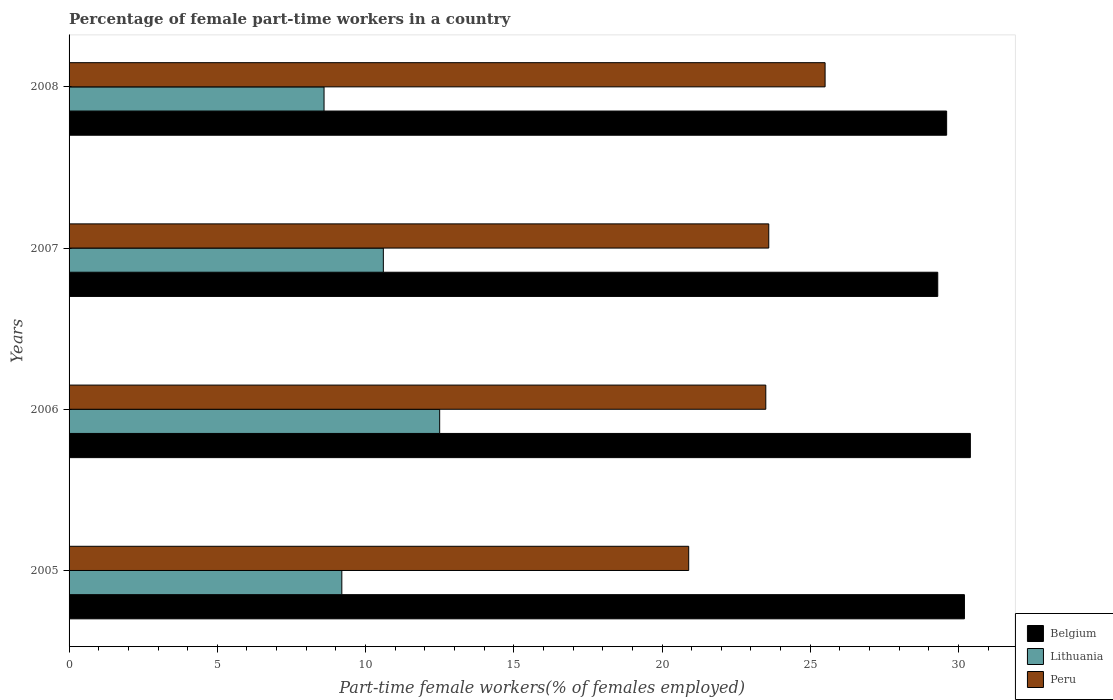How many groups of bars are there?
Provide a succinct answer. 4. Are the number of bars on each tick of the Y-axis equal?
Your answer should be very brief. Yes. What is the percentage of female part-time workers in Peru in 2008?
Ensure brevity in your answer.  25.5. Across all years, what is the maximum percentage of female part-time workers in Belgium?
Ensure brevity in your answer.  30.4. Across all years, what is the minimum percentage of female part-time workers in Peru?
Offer a very short reply. 20.9. In which year was the percentage of female part-time workers in Belgium minimum?
Keep it short and to the point. 2007. What is the total percentage of female part-time workers in Peru in the graph?
Offer a very short reply. 93.5. What is the difference between the percentage of female part-time workers in Belgium in 2006 and the percentage of female part-time workers in Lithuania in 2007?
Ensure brevity in your answer.  19.8. What is the average percentage of female part-time workers in Lithuania per year?
Provide a succinct answer. 10.23. In the year 2005, what is the difference between the percentage of female part-time workers in Belgium and percentage of female part-time workers in Peru?
Provide a succinct answer. 9.3. What is the ratio of the percentage of female part-time workers in Peru in 2006 to that in 2007?
Keep it short and to the point. 1. Is the percentage of female part-time workers in Belgium in 2005 less than that in 2008?
Your response must be concise. No. Is the difference between the percentage of female part-time workers in Belgium in 2007 and 2008 greater than the difference between the percentage of female part-time workers in Peru in 2007 and 2008?
Offer a very short reply. Yes. What is the difference between the highest and the second highest percentage of female part-time workers in Belgium?
Offer a terse response. 0.2. What is the difference between the highest and the lowest percentage of female part-time workers in Belgium?
Offer a terse response. 1.1. In how many years, is the percentage of female part-time workers in Belgium greater than the average percentage of female part-time workers in Belgium taken over all years?
Give a very brief answer. 2. Is the sum of the percentage of female part-time workers in Belgium in 2007 and 2008 greater than the maximum percentage of female part-time workers in Peru across all years?
Keep it short and to the point. Yes. What does the 3rd bar from the top in 2005 represents?
Offer a very short reply. Belgium. What does the 2nd bar from the bottom in 2006 represents?
Make the answer very short. Lithuania. How many bars are there?
Offer a terse response. 12. Are all the bars in the graph horizontal?
Provide a short and direct response. Yes. What is the difference between two consecutive major ticks on the X-axis?
Your answer should be very brief. 5. Are the values on the major ticks of X-axis written in scientific E-notation?
Provide a short and direct response. No. Does the graph contain any zero values?
Make the answer very short. No. Does the graph contain grids?
Give a very brief answer. No. Where does the legend appear in the graph?
Your answer should be compact. Bottom right. How many legend labels are there?
Give a very brief answer. 3. What is the title of the graph?
Provide a succinct answer. Percentage of female part-time workers in a country. What is the label or title of the X-axis?
Your response must be concise. Part-time female workers(% of females employed). What is the label or title of the Y-axis?
Provide a succinct answer. Years. What is the Part-time female workers(% of females employed) of Belgium in 2005?
Your response must be concise. 30.2. What is the Part-time female workers(% of females employed) of Lithuania in 2005?
Provide a short and direct response. 9.2. What is the Part-time female workers(% of females employed) of Peru in 2005?
Offer a very short reply. 20.9. What is the Part-time female workers(% of females employed) of Belgium in 2006?
Keep it short and to the point. 30.4. What is the Part-time female workers(% of females employed) of Lithuania in 2006?
Keep it short and to the point. 12.5. What is the Part-time female workers(% of females employed) of Belgium in 2007?
Offer a terse response. 29.3. What is the Part-time female workers(% of females employed) of Lithuania in 2007?
Offer a very short reply. 10.6. What is the Part-time female workers(% of females employed) in Peru in 2007?
Your answer should be compact. 23.6. What is the Part-time female workers(% of females employed) of Belgium in 2008?
Offer a very short reply. 29.6. What is the Part-time female workers(% of females employed) of Lithuania in 2008?
Offer a very short reply. 8.6. Across all years, what is the maximum Part-time female workers(% of females employed) in Belgium?
Ensure brevity in your answer.  30.4. Across all years, what is the maximum Part-time female workers(% of females employed) of Lithuania?
Make the answer very short. 12.5. Across all years, what is the minimum Part-time female workers(% of females employed) in Belgium?
Make the answer very short. 29.3. Across all years, what is the minimum Part-time female workers(% of females employed) of Lithuania?
Make the answer very short. 8.6. Across all years, what is the minimum Part-time female workers(% of females employed) in Peru?
Offer a terse response. 20.9. What is the total Part-time female workers(% of females employed) of Belgium in the graph?
Offer a terse response. 119.5. What is the total Part-time female workers(% of females employed) in Lithuania in the graph?
Keep it short and to the point. 40.9. What is the total Part-time female workers(% of females employed) in Peru in the graph?
Ensure brevity in your answer.  93.5. What is the difference between the Part-time female workers(% of females employed) in Belgium in 2005 and that in 2006?
Provide a succinct answer. -0.2. What is the difference between the Part-time female workers(% of females employed) in Peru in 2005 and that in 2006?
Keep it short and to the point. -2.6. What is the difference between the Part-time female workers(% of females employed) of Belgium in 2005 and that in 2007?
Make the answer very short. 0.9. What is the difference between the Part-time female workers(% of females employed) in Lithuania in 2005 and that in 2007?
Your answer should be compact. -1.4. What is the difference between the Part-time female workers(% of females employed) in Peru in 2005 and that in 2007?
Provide a short and direct response. -2.7. What is the difference between the Part-time female workers(% of females employed) in Belgium in 2005 and that in 2008?
Keep it short and to the point. 0.6. What is the difference between the Part-time female workers(% of females employed) of Lithuania in 2005 and that in 2008?
Offer a very short reply. 0.6. What is the difference between the Part-time female workers(% of females employed) of Peru in 2005 and that in 2008?
Ensure brevity in your answer.  -4.6. What is the difference between the Part-time female workers(% of females employed) in Peru in 2006 and that in 2007?
Provide a short and direct response. -0.1. What is the difference between the Part-time female workers(% of females employed) of Belgium in 2006 and that in 2008?
Provide a short and direct response. 0.8. What is the difference between the Part-time female workers(% of females employed) of Lithuania in 2007 and that in 2008?
Make the answer very short. 2. What is the difference between the Part-time female workers(% of females employed) of Belgium in 2005 and the Part-time female workers(% of females employed) of Lithuania in 2006?
Your response must be concise. 17.7. What is the difference between the Part-time female workers(% of females employed) in Lithuania in 2005 and the Part-time female workers(% of females employed) in Peru in 2006?
Ensure brevity in your answer.  -14.3. What is the difference between the Part-time female workers(% of females employed) in Belgium in 2005 and the Part-time female workers(% of females employed) in Lithuania in 2007?
Your response must be concise. 19.6. What is the difference between the Part-time female workers(% of females employed) in Lithuania in 2005 and the Part-time female workers(% of females employed) in Peru in 2007?
Keep it short and to the point. -14.4. What is the difference between the Part-time female workers(% of females employed) in Belgium in 2005 and the Part-time female workers(% of females employed) in Lithuania in 2008?
Offer a very short reply. 21.6. What is the difference between the Part-time female workers(% of females employed) of Lithuania in 2005 and the Part-time female workers(% of females employed) of Peru in 2008?
Offer a terse response. -16.3. What is the difference between the Part-time female workers(% of females employed) of Belgium in 2006 and the Part-time female workers(% of females employed) of Lithuania in 2007?
Your answer should be compact. 19.8. What is the difference between the Part-time female workers(% of females employed) of Belgium in 2006 and the Part-time female workers(% of females employed) of Peru in 2007?
Make the answer very short. 6.8. What is the difference between the Part-time female workers(% of females employed) in Belgium in 2006 and the Part-time female workers(% of females employed) in Lithuania in 2008?
Provide a short and direct response. 21.8. What is the difference between the Part-time female workers(% of females employed) in Belgium in 2006 and the Part-time female workers(% of females employed) in Peru in 2008?
Make the answer very short. 4.9. What is the difference between the Part-time female workers(% of females employed) in Lithuania in 2006 and the Part-time female workers(% of females employed) in Peru in 2008?
Offer a terse response. -13. What is the difference between the Part-time female workers(% of females employed) in Belgium in 2007 and the Part-time female workers(% of females employed) in Lithuania in 2008?
Provide a succinct answer. 20.7. What is the difference between the Part-time female workers(% of females employed) in Belgium in 2007 and the Part-time female workers(% of females employed) in Peru in 2008?
Your answer should be very brief. 3.8. What is the difference between the Part-time female workers(% of females employed) in Lithuania in 2007 and the Part-time female workers(% of females employed) in Peru in 2008?
Keep it short and to the point. -14.9. What is the average Part-time female workers(% of females employed) of Belgium per year?
Give a very brief answer. 29.88. What is the average Part-time female workers(% of females employed) in Lithuania per year?
Offer a very short reply. 10.22. What is the average Part-time female workers(% of females employed) of Peru per year?
Give a very brief answer. 23.38. In the year 2005, what is the difference between the Part-time female workers(% of females employed) of Belgium and Part-time female workers(% of females employed) of Peru?
Provide a short and direct response. 9.3. In the year 2005, what is the difference between the Part-time female workers(% of females employed) in Lithuania and Part-time female workers(% of females employed) in Peru?
Your answer should be very brief. -11.7. In the year 2006, what is the difference between the Part-time female workers(% of females employed) in Belgium and Part-time female workers(% of females employed) in Peru?
Your response must be concise. 6.9. In the year 2007, what is the difference between the Part-time female workers(% of females employed) in Belgium and Part-time female workers(% of females employed) in Lithuania?
Make the answer very short. 18.7. In the year 2007, what is the difference between the Part-time female workers(% of females employed) in Belgium and Part-time female workers(% of females employed) in Peru?
Your answer should be compact. 5.7. In the year 2007, what is the difference between the Part-time female workers(% of females employed) in Lithuania and Part-time female workers(% of females employed) in Peru?
Provide a short and direct response. -13. In the year 2008, what is the difference between the Part-time female workers(% of females employed) in Belgium and Part-time female workers(% of females employed) in Lithuania?
Your answer should be very brief. 21. In the year 2008, what is the difference between the Part-time female workers(% of females employed) of Lithuania and Part-time female workers(% of females employed) of Peru?
Give a very brief answer. -16.9. What is the ratio of the Part-time female workers(% of females employed) of Lithuania in 2005 to that in 2006?
Make the answer very short. 0.74. What is the ratio of the Part-time female workers(% of females employed) in Peru in 2005 to that in 2006?
Offer a very short reply. 0.89. What is the ratio of the Part-time female workers(% of females employed) in Belgium in 2005 to that in 2007?
Provide a succinct answer. 1.03. What is the ratio of the Part-time female workers(% of females employed) of Lithuania in 2005 to that in 2007?
Offer a terse response. 0.87. What is the ratio of the Part-time female workers(% of females employed) of Peru in 2005 to that in 2007?
Offer a terse response. 0.89. What is the ratio of the Part-time female workers(% of females employed) of Belgium in 2005 to that in 2008?
Your response must be concise. 1.02. What is the ratio of the Part-time female workers(% of females employed) of Lithuania in 2005 to that in 2008?
Ensure brevity in your answer.  1.07. What is the ratio of the Part-time female workers(% of females employed) in Peru in 2005 to that in 2008?
Provide a short and direct response. 0.82. What is the ratio of the Part-time female workers(% of females employed) of Belgium in 2006 to that in 2007?
Provide a succinct answer. 1.04. What is the ratio of the Part-time female workers(% of females employed) in Lithuania in 2006 to that in 2007?
Offer a terse response. 1.18. What is the ratio of the Part-time female workers(% of females employed) in Lithuania in 2006 to that in 2008?
Your response must be concise. 1.45. What is the ratio of the Part-time female workers(% of females employed) of Peru in 2006 to that in 2008?
Provide a succinct answer. 0.92. What is the ratio of the Part-time female workers(% of females employed) of Lithuania in 2007 to that in 2008?
Ensure brevity in your answer.  1.23. What is the ratio of the Part-time female workers(% of females employed) of Peru in 2007 to that in 2008?
Provide a succinct answer. 0.93. What is the difference between the highest and the second highest Part-time female workers(% of females employed) in Peru?
Your answer should be very brief. 1.9. 